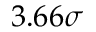<formula> <loc_0><loc_0><loc_500><loc_500>3 . 6 6 \sigma</formula> 